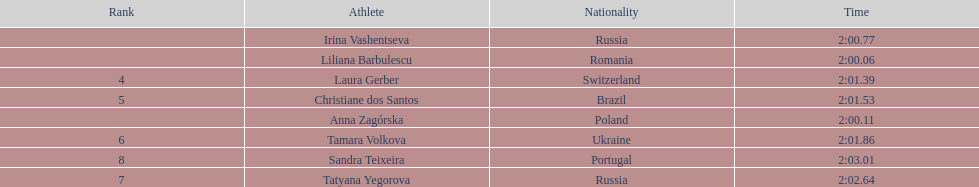Anna zagorska recieved 2nd place, what was her time? 2:00.11. 